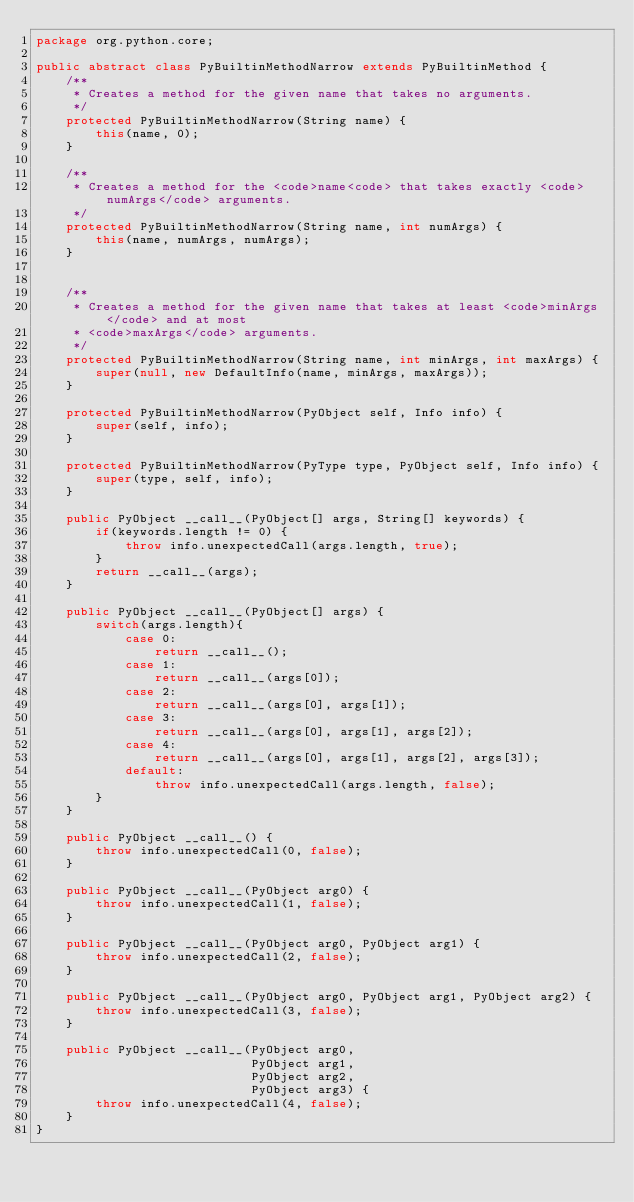Convert code to text. <code><loc_0><loc_0><loc_500><loc_500><_Java_>package org.python.core;

public abstract class PyBuiltinMethodNarrow extends PyBuiltinMethod {
    /**
     * Creates a method for the given name that takes no arguments.
     */
    protected PyBuiltinMethodNarrow(String name) {
        this(name, 0);
    }

    /**
     * Creates a method for the <code>name<code> that takes exactly <code>numArgs</code> arguments.
     */
    protected PyBuiltinMethodNarrow(String name, int numArgs) {
        this(name, numArgs, numArgs);
    }


    /**
     * Creates a method for the given name that takes at least <code>minArgs</code> and at most
     * <code>maxArgs</code> arguments.
     */
    protected PyBuiltinMethodNarrow(String name, int minArgs, int maxArgs) {
        super(null, new DefaultInfo(name, minArgs, maxArgs));
    }

    protected PyBuiltinMethodNarrow(PyObject self, Info info) {
        super(self, info);
    }

    protected PyBuiltinMethodNarrow(PyType type, PyObject self, Info info) {
        super(type, self, info);
    }

    public PyObject __call__(PyObject[] args, String[] keywords) {
        if(keywords.length != 0) {
            throw info.unexpectedCall(args.length, true);
        }
        return __call__(args);
    }

    public PyObject __call__(PyObject[] args) {
        switch(args.length){
            case 0:
                return __call__();
            case 1:
                return __call__(args[0]);
            case 2:
                return __call__(args[0], args[1]);
            case 3:
                return __call__(args[0], args[1], args[2]);
            case 4:
                return __call__(args[0], args[1], args[2], args[3]);
            default:
                throw info.unexpectedCall(args.length, false);
        }
    }

    public PyObject __call__() {
        throw info.unexpectedCall(0, false);
    }

    public PyObject __call__(PyObject arg0) {
        throw info.unexpectedCall(1, false);
    }

    public PyObject __call__(PyObject arg0, PyObject arg1) {
        throw info.unexpectedCall(2, false);
    }

    public PyObject __call__(PyObject arg0, PyObject arg1, PyObject arg2) {
        throw info.unexpectedCall(3, false);
    }

    public PyObject __call__(PyObject arg0,
                             PyObject arg1,
                             PyObject arg2,
                             PyObject arg3) {
        throw info.unexpectedCall(4, false);
    }
}
</code> 